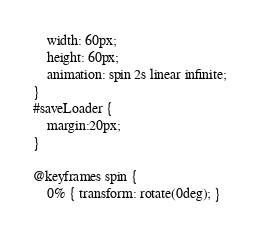<code> <loc_0><loc_0><loc_500><loc_500><_HTML_>    width: 60px;
    height: 60px;
    animation: spin 2s linear infinite;
}
#saveLoader {
    margin:20px;
}

@keyframes spin {
    0% { transform: rotate(0deg); }</code> 